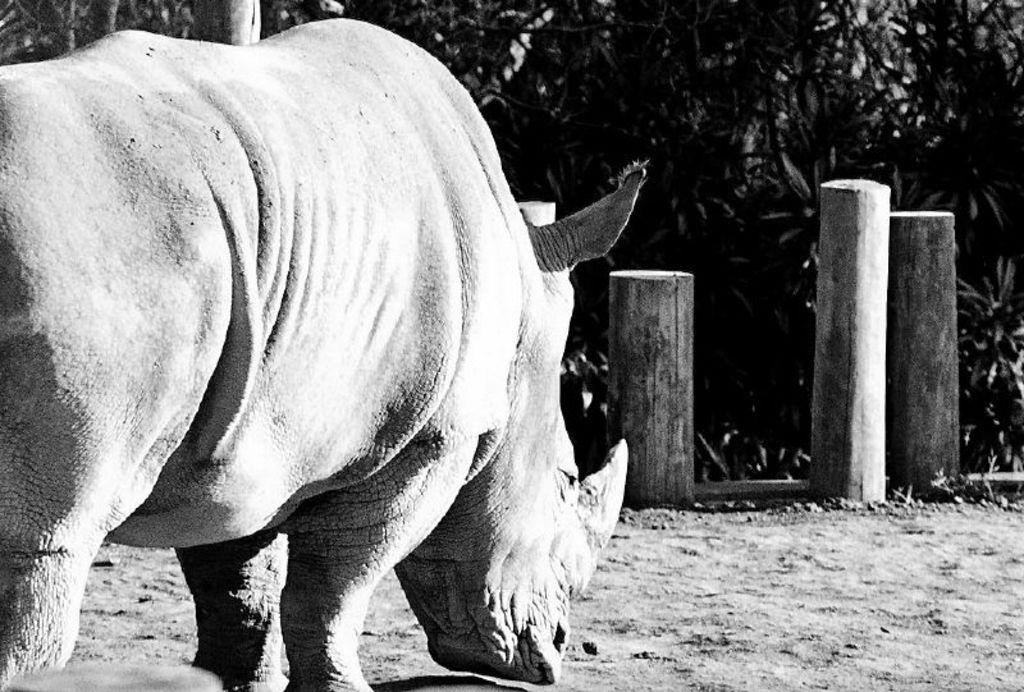What is on the ground in the image? There is an animal on the ground in the image. What can be seen in the background of the image? There are wooden poles and trees in the background of the image. What type of soup is being served at the station in the image? There is no station or soup present in the image; it features an animal on the ground and wooden poles and trees in the background. 